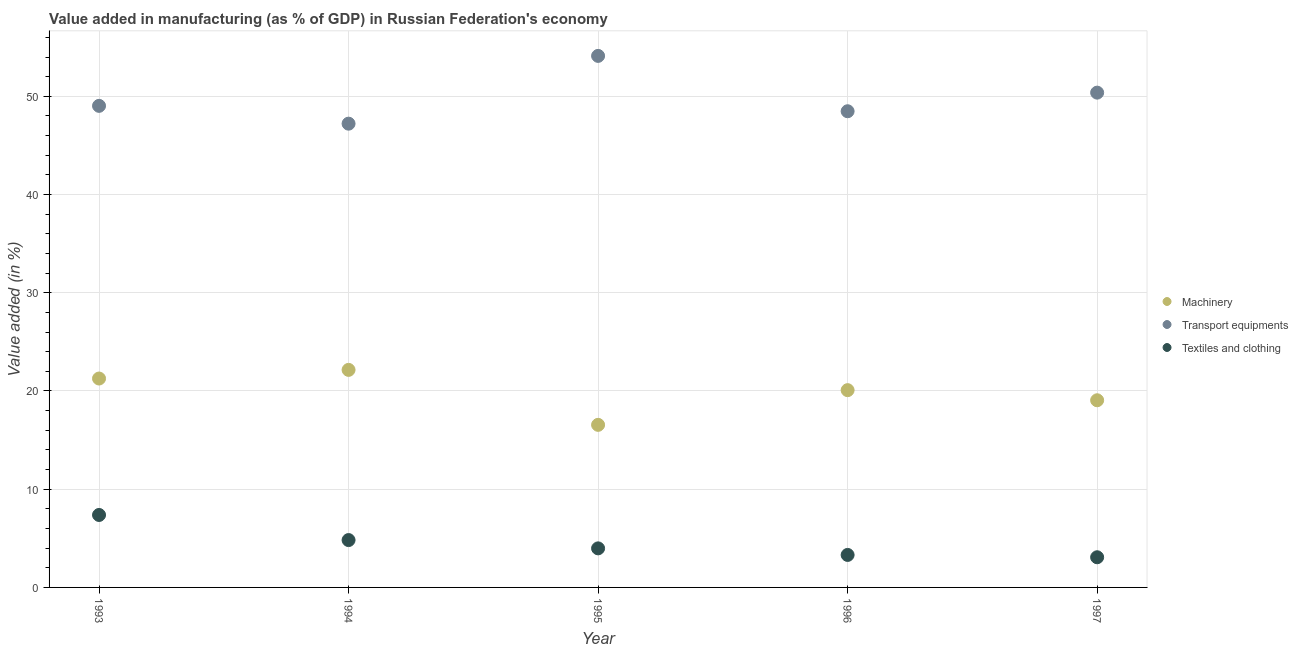How many different coloured dotlines are there?
Keep it short and to the point. 3. What is the value added in manufacturing machinery in 1994?
Provide a short and direct response. 22.15. Across all years, what is the maximum value added in manufacturing textile and clothing?
Your answer should be compact. 7.38. Across all years, what is the minimum value added in manufacturing machinery?
Your answer should be very brief. 16.55. In which year was the value added in manufacturing machinery maximum?
Offer a terse response. 1994. What is the total value added in manufacturing machinery in the graph?
Your response must be concise. 99.11. What is the difference between the value added in manufacturing textile and clothing in 1995 and that in 1996?
Provide a succinct answer. 0.67. What is the difference between the value added in manufacturing machinery in 1996 and the value added in manufacturing transport equipments in 1995?
Keep it short and to the point. -34.03. What is the average value added in manufacturing textile and clothing per year?
Your response must be concise. 4.51. In the year 1993, what is the difference between the value added in manufacturing textile and clothing and value added in manufacturing machinery?
Provide a succinct answer. -13.89. What is the ratio of the value added in manufacturing textile and clothing in 1993 to that in 1997?
Ensure brevity in your answer.  2.4. Is the difference between the value added in manufacturing textile and clothing in 1994 and 1995 greater than the difference between the value added in manufacturing machinery in 1994 and 1995?
Offer a terse response. No. What is the difference between the highest and the second highest value added in manufacturing machinery?
Your answer should be very brief. 0.88. What is the difference between the highest and the lowest value added in manufacturing machinery?
Your response must be concise. 5.6. Is it the case that in every year, the sum of the value added in manufacturing machinery and value added in manufacturing transport equipments is greater than the value added in manufacturing textile and clothing?
Give a very brief answer. Yes. Does the value added in manufacturing textile and clothing monotonically increase over the years?
Provide a short and direct response. No. Is the value added in manufacturing machinery strictly less than the value added in manufacturing transport equipments over the years?
Provide a short and direct response. Yes. How many dotlines are there?
Your response must be concise. 3. Does the graph contain any zero values?
Give a very brief answer. No. Does the graph contain grids?
Your answer should be compact. Yes. What is the title of the graph?
Your response must be concise. Value added in manufacturing (as % of GDP) in Russian Federation's economy. What is the label or title of the Y-axis?
Ensure brevity in your answer.  Value added (in %). What is the Value added (in %) in Machinery in 1993?
Give a very brief answer. 21.27. What is the Value added (in %) of Transport equipments in 1993?
Provide a succinct answer. 49.03. What is the Value added (in %) of Textiles and clothing in 1993?
Keep it short and to the point. 7.38. What is the Value added (in %) in Machinery in 1994?
Make the answer very short. 22.15. What is the Value added (in %) in Transport equipments in 1994?
Offer a terse response. 47.22. What is the Value added (in %) in Textiles and clothing in 1994?
Offer a terse response. 4.82. What is the Value added (in %) of Machinery in 1995?
Make the answer very short. 16.55. What is the Value added (in %) in Transport equipments in 1995?
Your answer should be compact. 54.12. What is the Value added (in %) of Textiles and clothing in 1995?
Provide a short and direct response. 3.98. What is the Value added (in %) of Machinery in 1996?
Ensure brevity in your answer.  20.09. What is the Value added (in %) of Transport equipments in 1996?
Offer a very short reply. 48.48. What is the Value added (in %) of Textiles and clothing in 1996?
Your answer should be compact. 3.31. What is the Value added (in %) in Machinery in 1997?
Make the answer very short. 19.06. What is the Value added (in %) in Transport equipments in 1997?
Offer a very short reply. 50.38. What is the Value added (in %) of Textiles and clothing in 1997?
Provide a short and direct response. 3.07. Across all years, what is the maximum Value added (in %) in Machinery?
Offer a very short reply. 22.15. Across all years, what is the maximum Value added (in %) in Transport equipments?
Your answer should be very brief. 54.12. Across all years, what is the maximum Value added (in %) in Textiles and clothing?
Your response must be concise. 7.38. Across all years, what is the minimum Value added (in %) of Machinery?
Provide a short and direct response. 16.55. Across all years, what is the minimum Value added (in %) of Transport equipments?
Offer a very short reply. 47.22. Across all years, what is the minimum Value added (in %) in Textiles and clothing?
Your answer should be compact. 3.07. What is the total Value added (in %) in Machinery in the graph?
Provide a short and direct response. 99.11. What is the total Value added (in %) of Transport equipments in the graph?
Offer a terse response. 249.22. What is the total Value added (in %) in Textiles and clothing in the graph?
Offer a very short reply. 22.56. What is the difference between the Value added (in %) in Machinery in 1993 and that in 1994?
Make the answer very short. -0.88. What is the difference between the Value added (in %) of Transport equipments in 1993 and that in 1994?
Provide a succinct answer. 1.81. What is the difference between the Value added (in %) of Textiles and clothing in 1993 and that in 1994?
Ensure brevity in your answer.  2.56. What is the difference between the Value added (in %) of Machinery in 1993 and that in 1995?
Your answer should be compact. 4.72. What is the difference between the Value added (in %) in Transport equipments in 1993 and that in 1995?
Offer a very short reply. -5.09. What is the difference between the Value added (in %) in Textiles and clothing in 1993 and that in 1995?
Offer a terse response. 3.4. What is the difference between the Value added (in %) in Machinery in 1993 and that in 1996?
Provide a short and direct response. 1.18. What is the difference between the Value added (in %) of Transport equipments in 1993 and that in 1996?
Give a very brief answer. 0.55. What is the difference between the Value added (in %) of Textiles and clothing in 1993 and that in 1996?
Offer a terse response. 4.07. What is the difference between the Value added (in %) in Machinery in 1993 and that in 1997?
Your answer should be compact. 2.21. What is the difference between the Value added (in %) of Transport equipments in 1993 and that in 1997?
Your response must be concise. -1.35. What is the difference between the Value added (in %) in Textiles and clothing in 1993 and that in 1997?
Provide a short and direct response. 4.31. What is the difference between the Value added (in %) in Machinery in 1994 and that in 1995?
Your answer should be very brief. 5.6. What is the difference between the Value added (in %) of Transport equipments in 1994 and that in 1995?
Offer a terse response. -6.9. What is the difference between the Value added (in %) in Textiles and clothing in 1994 and that in 1995?
Keep it short and to the point. 0.85. What is the difference between the Value added (in %) in Machinery in 1994 and that in 1996?
Provide a short and direct response. 2.06. What is the difference between the Value added (in %) of Transport equipments in 1994 and that in 1996?
Offer a terse response. -1.27. What is the difference between the Value added (in %) of Textiles and clothing in 1994 and that in 1996?
Ensure brevity in your answer.  1.51. What is the difference between the Value added (in %) in Machinery in 1994 and that in 1997?
Give a very brief answer. 3.09. What is the difference between the Value added (in %) of Transport equipments in 1994 and that in 1997?
Your answer should be very brief. -3.16. What is the difference between the Value added (in %) in Textiles and clothing in 1994 and that in 1997?
Your response must be concise. 1.75. What is the difference between the Value added (in %) in Machinery in 1995 and that in 1996?
Ensure brevity in your answer.  -3.53. What is the difference between the Value added (in %) in Transport equipments in 1995 and that in 1996?
Your answer should be compact. 5.64. What is the difference between the Value added (in %) of Textiles and clothing in 1995 and that in 1996?
Ensure brevity in your answer.  0.67. What is the difference between the Value added (in %) in Machinery in 1995 and that in 1997?
Offer a very short reply. -2.5. What is the difference between the Value added (in %) of Transport equipments in 1995 and that in 1997?
Ensure brevity in your answer.  3.74. What is the difference between the Value added (in %) of Textiles and clothing in 1995 and that in 1997?
Your answer should be compact. 0.9. What is the difference between the Value added (in %) in Machinery in 1996 and that in 1997?
Offer a very short reply. 1.03. What is the difference between the Value added (in %) in Transport equipments in 1996 and that in 1997?
Provide a short and direct response. -1.89. What is the difference between the Value added (in %) in Textiles and clothing in 1996 and that in 1997?
Ensure brevity in your answer.  0.24. What is the difference between the Value added (in %) in Machinery in 1993 and the Value added (in %) in Transport equipments in 1994?
Offer a very short reply. -25.95. What is the difference between the Value added (in %) in Machinery in 1993 and the Value added (in %) in Textiles and clothing in 1994?
Give a very brief answer. 16.45. What is the difference between the Value added (in %) of Transport equipments in 1993 and the Value added (in %) of Textiles and clothing in 1994?
Provide a succinct answer. 44.21. What is the difference between the Value added (in %) in Machinery in 1993 and the Value added (in %) in Transport equipments in 1995?
Offer a very short reply. -32.85. What is the difference between the Value added (in %) of Machinery in 1993 and the Value added (in %) of Textiles and clothing in 1995?
Your answer should be very brief. 17.29. What is the difference between the Value added (in %) in Transport equipments in 1993 and the Value added (in %) in Textiles and clothing in 1995?
Your response must be concise. 45.05. What is the difference between the Value added (in %) in Machinery in 1993 and the Value added (in %) in Transport equipments in 1996?
Offer a terse response. -27.21. What is the difference between the Value added (in %) in Machinery in 1993 and the Value added (in %) in Textiles and clothing in 1996?
Provide a succinct answer. 17.96. What is the difference between the Value added (in %) in Transport equipments in 1993 and the Value added (in %) in Textiles and clothing in 1996?
Offer a terse response. 45.72. What is the difference between the Value added (in %) in Machinery in 1993 and the Value added (in %) in Transport equipments in 1997?
Keep it short and to the point. -29.11. What is the difference between the Value added (in %) of Machinery in 1993 and the Value added (in %) of Textiles and clothing in 1997?
Provide a succinct answer. 18.2. What is the difference between the Value added (in %) of Transport equipments in 1993 and the Value added (in %) of Textiles and clothing in 1997?
Keep it short and to the point. 45.96. What is the difference between the Value added (in %) in Machinery in 1994 and the Value added (in %) in Transport equipments in 1995?
Offer a very short reply. -31.97. What is the difference between the Value added (in %) in Machinery in 1994 and the Value added (in %) in Textiles and clothing in 1995?
Keep it short and to the point. 18.17. What is the difference between the Value added (in %) in Transport equipments in 1994 and the Value added (in %) in Textiles and clothing in 1995?
Provide a short and direct response. 43.24. What is the difference between the Value added (in %) in Machinery in 1994 and the Value added (in %) in Transport equipments in 1996?
Your answer should be very brief. -26.33. What is the difference between the Value added (in %) of Machinery in 1994 and the Value added (in %) of Textiles and clothing in 1996?
Provide a succinct answer. 18.84. What is the difference between the Value added (in %) in Transport equipments in 1994 and the Value added (in %) in Textiles and clothing in 1996?
Keep it short and to the point. 43.91. What is the difference between the Value added (in %) of Machinery in 1994 and the Value added (in %) of Transport equipments in 1997?
Provide a short and direct response. -28.23. What is the difference between the Value added (in %) of Machinery in 1994 and the Value added (in %) of Textiles and clothing in 1997?
Ensure brevity in your answer.  19.08. What is the difference between the Value added (in %) of Transport equipments in 1994 and the Value added (in %) of Textiles and clothing in 1997?
Keep it short and to the point. 44.15. What is the difference between the Value added (in %) of Machinery in 1995 and the Value added (in %) of Transport equipments in 1996?
Your answer should be very brief. -31.93. What is the difference between the Value added (in %) in Machinery in 1995 and the Value added (in %) in Textiles and clothing in 1996?
Make the answer very short. 13.24. What is the difference between the Value added (in %) in Transport equipments in 1995 and the Value added (in %) in Textiles and clothing in 1996?
Provide a short and direct response. 50.81. What is the difference between the Value added (in %) of Machinery in 1995 and the Value added (in %) of Transport equipments in 1997?
Offer a terse response. -33.82. What is the difference between the Value added (in %) in Machinery in 1995 and the Value added (in %) in Textiles and clothing in 1997?
Offer a terse response. 13.48. What is the difference between the Value added (in %) of Transport equipments in 1995 and the Value added (in %) of Textiles and clothing in 1997?
Ensure brevity in your answer.  51.05. What is the difference between the Value added (in %) of Machinery in 1996 and the Value added (in %) of Transport equipments in 1997?
Keep it short and to the point. -30.29. What is the difference between the Value added (in %) in Machinery in 1996 and the Value added (in %) in Textiles and clothing in 1997?
Your answer should be compact. 17.01. What is the difference between the Value added (in %) of Transport equipments in 1996 and the Value added (in %) of Textiles and clothing in 1997?
Ensure brevity in your answer.  45.41. What is the average Value added (in %) of Machinery per year?
Offer a terse response. 19.82. What is the average Value added (in %) in Transport equipments per year?
Your response must be concise. 49.84. What is the average Value added (in %) in Textiles and clothing per year?
Offer a terse response. 4.51. In the year 1993, what is the difference between the Value added (in %) in Machinery and Value added (in %) in Transport equipments?
Make the answer very short. -27.76. In the year 1993, what is the difference between the Value added (in %) of Machinery and Value added (in %) of Textiles and clothing?
Keep it short and to the point. 13.89. In the year 1993, what is the difference between the Value added (in %) in Transport equipments and Value added (in %) in Textiles and clothing?
Offer a terse response. 41.65. In the year 1994, what is the difference between the Value added (in %) in Machinery and Value added (in %) in Transport equipments?
Your answer should be compact. -25.07. In the year 1994, what is the difference between the Value added (in %) of Machinery and Value added (in %) of Textiles and clothing?
Your response must be concise. 17.33. In the year 1994, what is the difference between the Value added (in %) of Transport equipments and Value added (in %) of Textiles and clothing?
Offer a terse response. 42.4. In the year 1995, what is the difference between the Value added (in %) of Machinery and Value added (in %) of Transport equipments?
Keep it short and to the point. -37.56. In the year 1995, what is the difference between the Value added (in %) of Machinery and Value added (in %) of Textiles and clothing?
Provide a succinct answer. 12.58. In the year 1995, what is the difference between the Value added (in %) in Transport equipments and Value added (in %) in Textiles and clothing?
Make the answer very short. 50.14. In the year 1996, what is the difference between the Value added (in %) in Machinery and Value added (in %) in Transport equipments?
Provide a short and direct response. -28.4. In the year 1996, what is the difference between the Value added (in %) of Machinery and Value added (in %) of Textiles and clothing?
Offer a terse response. 16.78. In the year 1996, what is the difference between the Value added (in %) of Transport equipments and Value added (in %) of Textiles and clothing?
Offer a terse response. 45.17. In the year 1997, what is the difference between the Value added (in %) in Machinery and Value added (in %) in Transport equipments?
Provide a short and direct response. -31.32. In the year 1997, what is the difference between the Value added (in %) of Machinery and Value added (in %) of Textiles and clothing?
Keep it short and to the point. 15.98. In the year 1997, what is the difference between the Value added (in %) in Transport equipments and Value added (in %) in Textiles and clothing?
Provide a short and direct response. 47.3. What is the ratio of the Value added (in %) in Machinery in 1993 to that in 1994?
Offer a terse response. 0.96. What is the ratio of the Value added (in %) in Transport equipments in 1993 to that in 1994?
Keep it short and to the point. 1.04. What is the ratio of the Value added (in %) of Textiles and clothing in 1993 to that in 1994?
Make the answer very short. 1.53. What is the ratio of the Value added (in %) of Machinery in 1993 to that in 1995?
Give a very brief answer. 1.28. What is the ratio of the Value added (in %) of Transport equipments in 1993 to that in 1995?
Offer a very short reply. 0.91. What is the ratio of the Value added (in %) of Textiles and clothing in 1993 to that in 1995?
Your response must be concise. 1.86. What is the ratio of the Value added (in %) in Machinery in 1993 to that in 1996?
Provide a succinct answer. 1.06. What is the ratio of the Value added (in %) in Transport equipments in 1993 to that in 1996?
Your answer should be compact. 1.01. What is the ratio of the Value added (in %) in Textiles and clothing in 1993 to that in 1996?
Offer a very short reply. 2.23. What is the ratio of the Value added (in %) of Machinery in 1993 to that in 1997?
Keep it short and to the point. 1.12. What is the ratio of the Value added (in %) in Transport equipments in 1993 to that in 1997?
Your answer should be compact. 0.97. What is the ratio of the Value added (in %) in Textiles and clothing in 1993 to that in 1997?
Your answer should be compact. 2.4. What is the ratio of the Value added (in %) of Machinery in 1994 to that in 1995?
Provide a short and direct response. 1.34. What is the ratio of the Value added (in %) in Transport equipments in 1994 to that in 1995?
Ensure brevity in your answer.  0.87. What is the ratio of the Value added (in %) of Textiles and clothing in 1994 to that in 1995?
Give a very brief answer. 1.21. What is the ratio of the Value added (in %) in Machinery in 1994 to that in 1996?
Your response must be concise. 1.1. What is the ratio of the Value added (in %) of Transport equipments in 1994 to that in 1996?
Offer a very short reply. 0.97. What is the ratio of the Value added (in %) of Textiles and clothing in 1994 to that in 1996?
Give a very brief answer. 1.46. What is the ratio of the Value added (in %) in Machinery in 1994 to that in 1997?
Your answer should be very brief. 1.16. What is the ratio of the Value added (in %) in Transport equipments in 1994 to that in 1997?
Your answer should be compact. 0.94. What is the ratio of the Value added (in %) in Textiles and clothing in 1994 to that in 1997?
Keep it short and to the point. 1.57. What is the ratio of the Value added (in %) of Machinery in 1995 to that in 1996?
Your answer should be compact. 0.82. What is the ratio of the Value added (in %) in Transport equipments in 1995 to that in 1996?
Offer a terse response. 1.12. What is the ratio of the Value added (in %) of Textiles and clothing in 1995 to that in 1996?
Make the answer very short. 1.2. What is the ratio of the Value added (in %) in Machinery in 1995 to that in 1997?
Give a very brief answer. 0.87. What is the ratio of the Value added (in %) in Transport equipments in 1995 to that in 1997?
Provide a succinct answer. 1.07. What is the ratio of the Value added (in %) of Textiles and clothing in 1995 to that in 1997?
Offer a very short reply. 1.29. What is the ratio of the Value added (in %) of Machinery in 1996 to that in 1997?
Provide a succinct answer. 1.05. What is the ratio of the Value added (in %) of Transport equipments in 1996 to that in 1997?
Make the answer very short. 0.96. What is the ratio of the Value added (in %) in Textiles and clothing in 1996 to that in 1997?
Your answer should be compact. 1.08. What is the difference between the highest and the second highest Value added (in %) in Machinery?
Ensure brevity in your answer.  0.88. What is the difference between the highest and the second highest Value added (in %) of Transport equipments?
Ensure brevity in your answer.  3.74. What is the difference between the highest and the second highest Value added (in %) of Textiles and clothing?
Your response must be concise. 2.56. What is the difference between the highest and the lowest Value added (in %) of Machinery?
Give a very brief answer. 5.6. What is the difference between the highest and the lowest Value added (in %) in Transport equipments?
Offer a very short reply. 6.9. What is the difference between the highest and the lowest Value added (in %) in Textiles and clothing?
Provide a succinct answer. 4.31. 